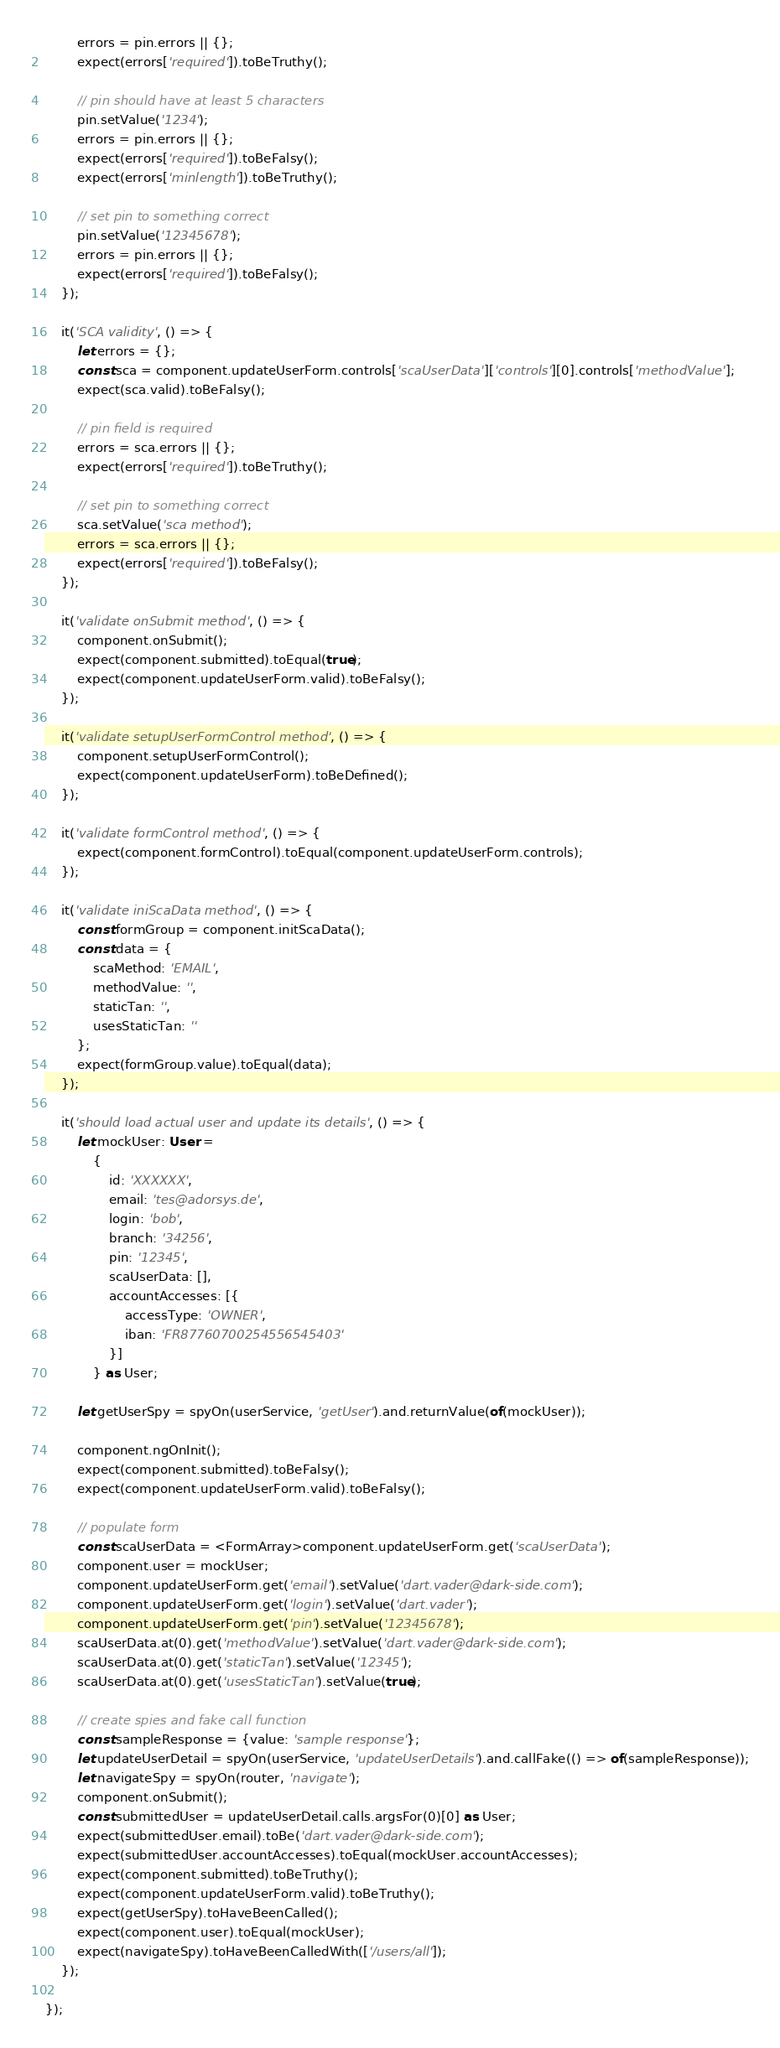Convert code to text. <code><loc_0><loc_0><loc_500><loc_500><_TypeScript_>        errors = pin.errors || {};
        expect(errors['required']).toBeTruthy();

        // pin should have at least 5 characters
        pin.setValue('1234');
        errors = pin.errors || {};
        expect(errors['required']).toBeFalsy();
        expect(errors['minlength']).toBeTruthy();

        // set pin to something correct
        pin.setValue('12345678');
        errors = pin.errors || {};
        expect(errors['required']).toBeFalsy();
    });

    it('SCA validity', () => {
        let errors = {};
        const sca = component.updateUserForm.controls['scaUserData']['controls'][0].controls['methodValue'];
        expect(sca.valid).toBeFalsy();

        // pin field is required
        errors = sca.errors || {};
        expect(errors['required']).toBeTruthy();

        // set pin to something correct
        sca.setValue('sca method');
        errors = sca.errors || {};
        expect(errors['required']).toBeFalsy();
    });

    it('validate onSubmit method', () => {
        component.onSubmit();
        expect(component.submitted).toEqual(true);
        expect(component.updateUserForm.valid).toBeFalsy();
    });

    it('validate setupUserFormControl method', () => {
        component.setupUserFormControl();
        expect(component.updateUserForm).toBeDefined();
    });

    it('validate formControl method', () => {
        expect(component.formControl).toEqual(component.updateUserForm.controls);
    });

    it('validate iniScaData method', () => {
        const formGroup = component.initScaData();
        const data = {
            scaMethod: 'EMAIL',
            methodValue: '',
            staticTan: '',
            usesStaticTan: ''
        };
        expect(formGroup.value).toEqual(data);
    });

    it('should load actual user and update its details', () => {
        let mockUser: User =
            {
                id: 'XXXXXX',
                email: 'tes@adorsys.de',
                login: 'bob',
                branch: '34256',
                pin: '12345',
                scaUserData: [],
                accountAccesses: [{
                    accessType: 'OWNER',
                    iban: 'FR87760700254556545403'
                }]
            } as User;

        let getUserSpy = spyOn(userService, 'getUser').and.returnValue(of(mockUser));

        component.ngOnInit();
        expect(component.submitted).toBeFalsy();
        expect(component.updateUserForm.valid).toBeFalsy();

        // populate form
        const scaUserData = <FormArray>component.updateUserForm.get('scaUserData');
        component.user = mockUser;
        component.updateUserForm.get('email').setValue('dart.vader@dark-side.com');
        component.updateUserForm.get('login').setValue('dart.vader');
        component.updateUserForm.get('pin').setValue('12345678');
        scaUserData.at(0).get('methodValue').setValue('dart.vader@dark-side.com');
        scaUserData.at(0).get('staticTan').setValue('12345');
        scaUserData.at(0).get('usesStaticTan').setValue(true);

        // create spies and fake call function
        const sampleResponse = {value: 'sample response'};
        let updateUserDetail = spyOn(userService, 'updateUserDetails').and.callFake(() => of(sampleResponse));
        let navigateSpy = spyOn(router, 'navigate');
        component.onSubmit();
        const submittedUser = updateUserDetail.calls.argsFor(0)[0] as User;
        expect(submittedUser.email).toBe('dart.vader@dark-side.com');
        expect(submittedUser.accountAccesses).toEqual(mockUser.accountAccesses);
        expect(component.submitted).toBeTruthy();
        expect(component.updateUserForm.valid).toBeTruthy();
        expect(getUserSpy).toHaveBeenCalled();
        expect(component.user).toEqual(mockUser);
        expect(navigateSpy).toHaveBeenCalledWith(['/users/all']);
    });

});
</code> 